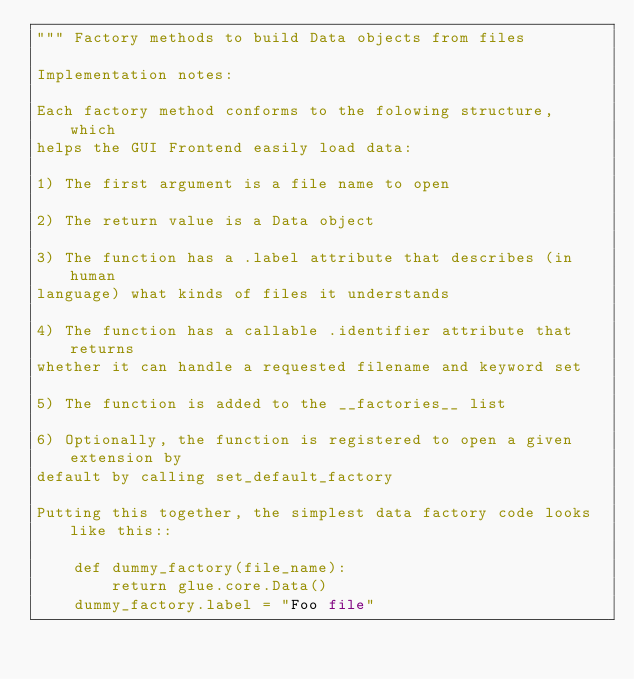<code> <loc_0><loc_0><loc_500><loc_500><_Python_>""" Factory methods to build Data objects from files

Implementation notes:

Each factory method conforms to the folowing structure, which
helps the GUI Frontend easily load data:

1) The first argument is a file name to open

2) The return value is a Data object

3) The function has a .label attribute that describes (in human
language) what kinds of files it understands

4) The function has a callable .identifier attribute that returns
whether it can handle a requested filename and keyword set

5) The function is added to the __factories__ list

6) Optionally, the function is registered to open a given extension by
default by calling set_default_factory

Putting this together, the simplest data factory code looks like this::

    def dummy_factory(file_name):
        return glue.core.Data()
    dummy_factory.label = "Foo file"</code> 